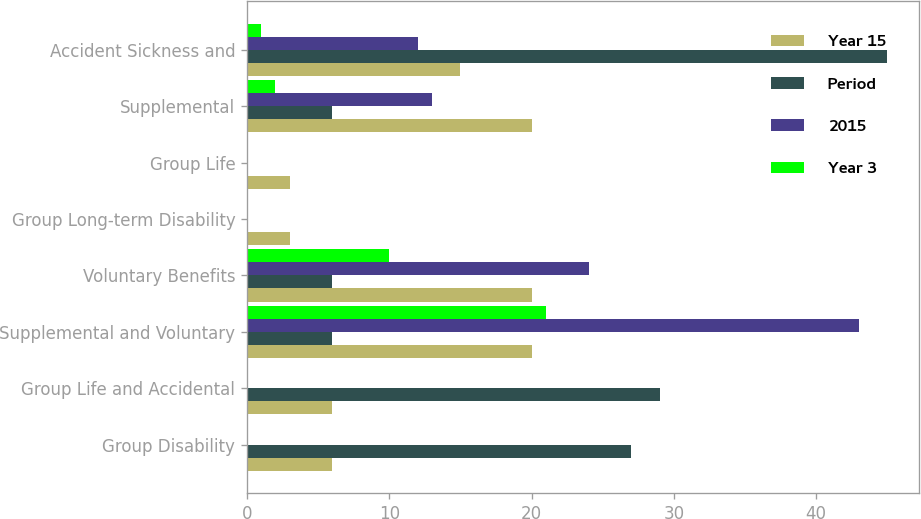Convert chart. <chart><loc_0><loc_0><loc_500><loc_500><stacked_bar_chart><ecel><fcel>Group Disability<fcel>Group Life and Accidental<fcel>Supplemental and Voluntary<fcel>Voluntary Benefits<fcel>Group Long-term Disability<fcel>Group Life<fcel>Supplemental<fcel>Accident Sickness and<nl><fcel>Year 15<fcel>6<fcel>6<fcel>20<fcel>20<fcel>3<fcel>3<fcel>20<fcel>15<nl><fcel>Period<fcel>27<fcel>29<fcel>6<fcel>6<fcel>0<fcel>0<fcel>6<fcel>45<nl><fcel>2015<fcel>0<fcel>0<fcel>43<fcel>24<fcel>0<fcel>0<fcel>13<fcel>12<nl><fcel>Year 3<fcel>0<fcel>0<fcel>21<fcel>10<fcel>0<fcel>0<fcel>2<fcel>1<nl></chart> 